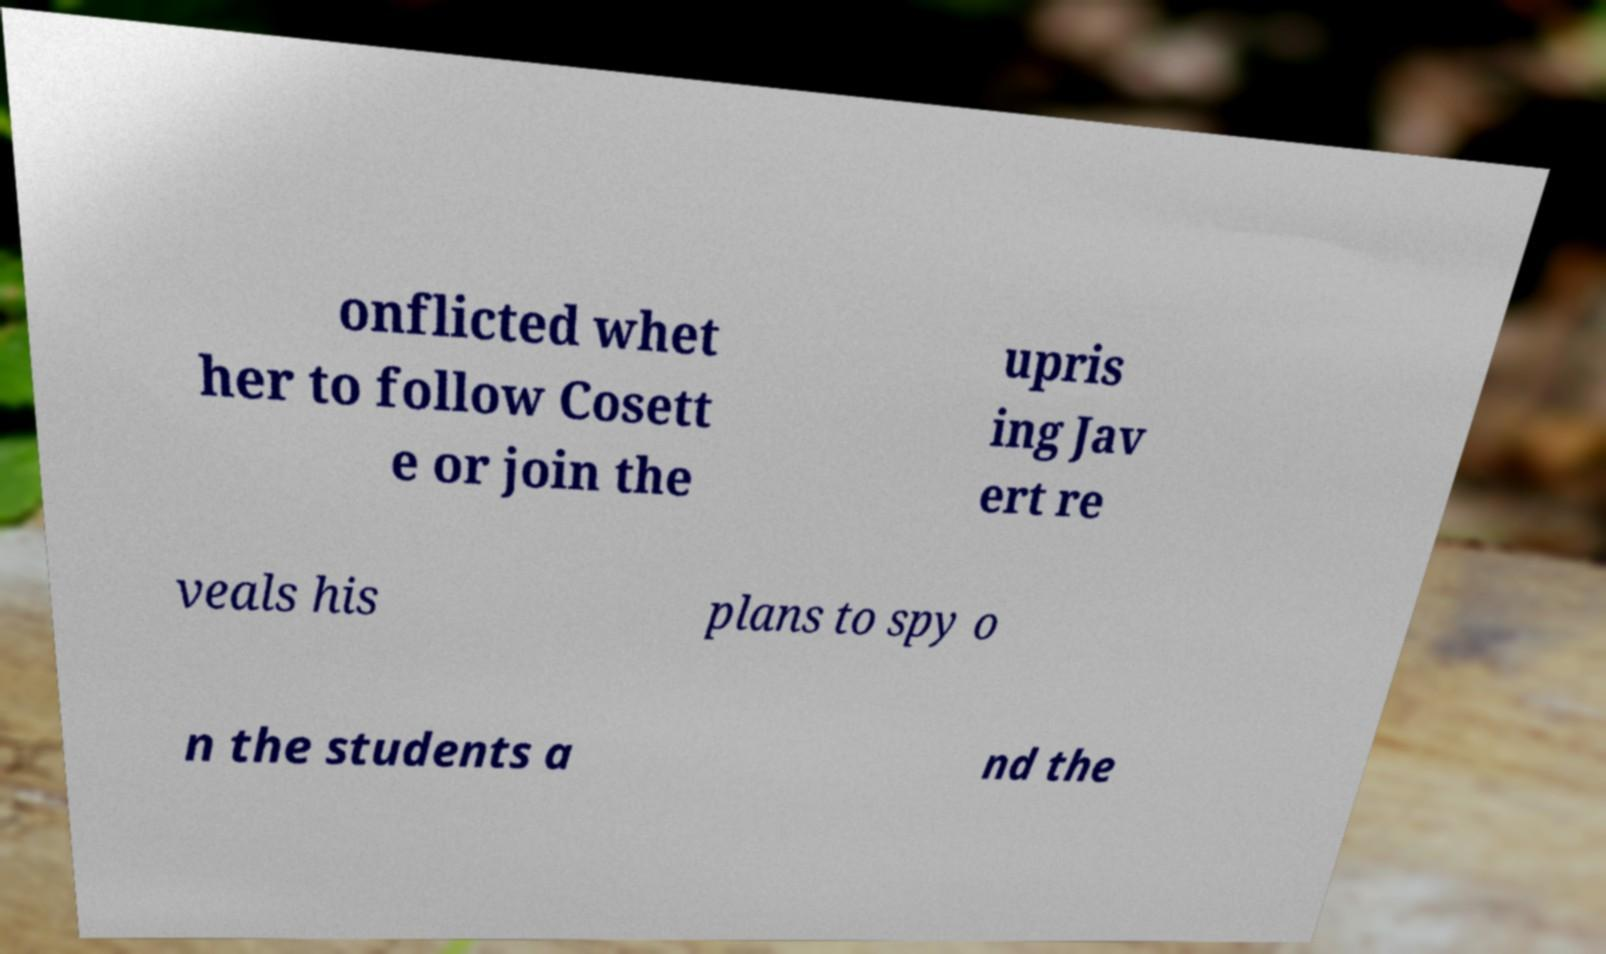There's text embedded in this image that I need extracted. Can you transcribe it verbatim? onflicted whet her to follow Cosett e or join the upris ing Jav ert re veals his plans to spy o n the students a nd the 